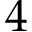Convert formula to latex. <formula><loc_0><loc_0><loc_500><loc_500>4</formula> 